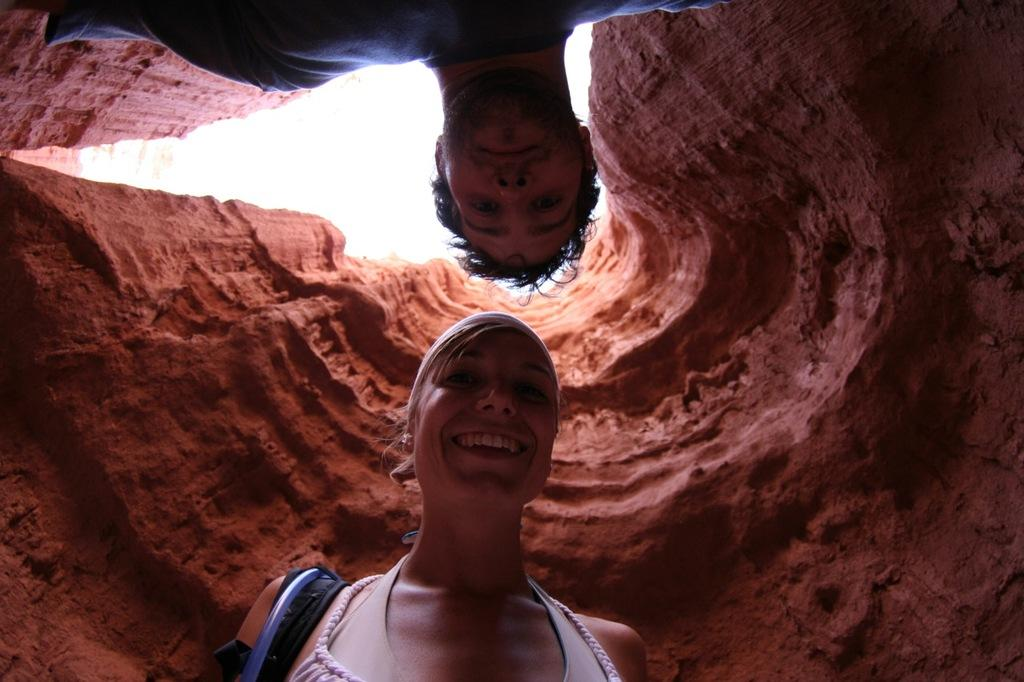How many people are in the image? There are two people in the image. What is the woman wearing in the image? The woman is wearing a pink dress. What is the man wearing in the image? The man is wearing a blue dress. What is visible at the top of the image? The sky is visible at the top of the image. What type of trousers is the woman wearing in the image? The woman is not wearing trousers in the image; she is wearing a dress. What offer is the man making to the woman in the image? There is no indication of an offer being made in the image; it only shows two people wearing dresses. 